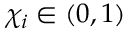<formula> <loc_0><loc_0><loc_500><loc_500>\chi _ { i } \in ( 0 , 1 )</formula> 